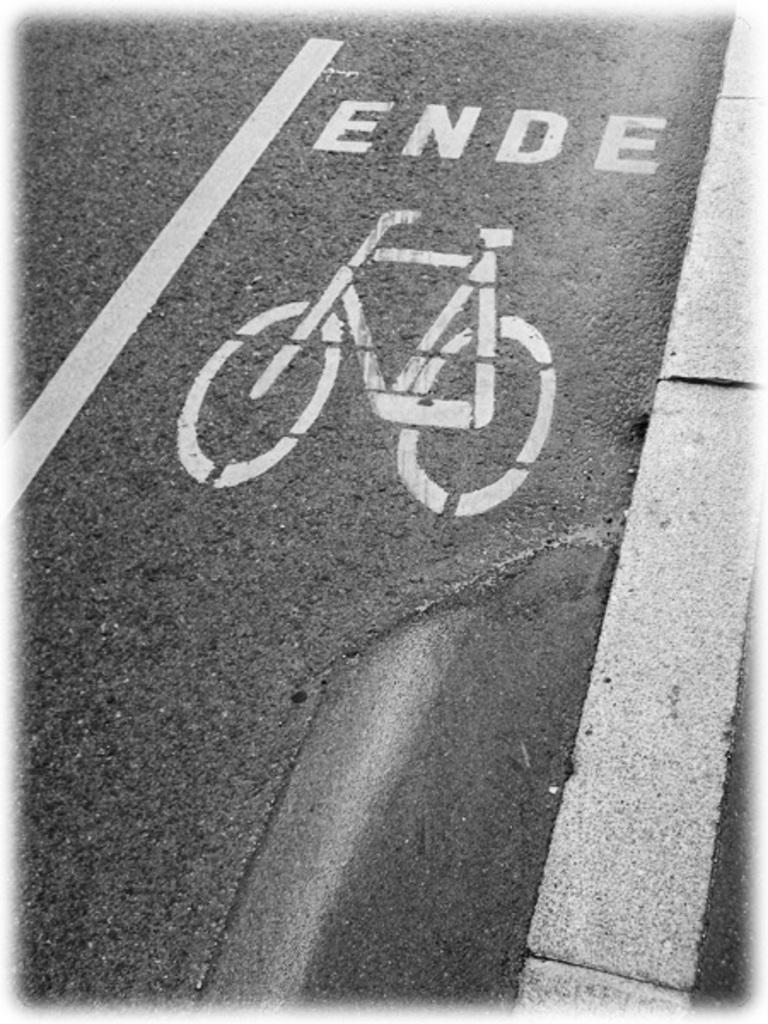What is present on the road in the front of the image? There is text and a painting of a cycle on the road in the front of the image. What type of trousers can be seen in the image? There are no trousers present in the image. What historical discovery is depicted in the image? There is no historical discovery depicted in the image; it features text and a painting of a cycle on the road. 